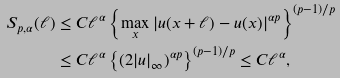Convert formula to latex. <formula><loc_0><loc_0><loc_500><loc_500>S _ { p , \alpha } ( \ell ) & \leq C \ell ^ { \alpha } \left \{ \max _ { x } | u ( x + \ell ) - u ( x ) | ^ { \alpha p } \right \} ^ { ( p - 1 ) / p } \\ & \leq C \ell ^ { \alpha } \left \{ ( 2 | u | _ { \infty } ) ^ { \alpha p } \right \} ^ { ( p - 1 ) / p } \leq C \ell ^ { \alpha } ,</formula> 